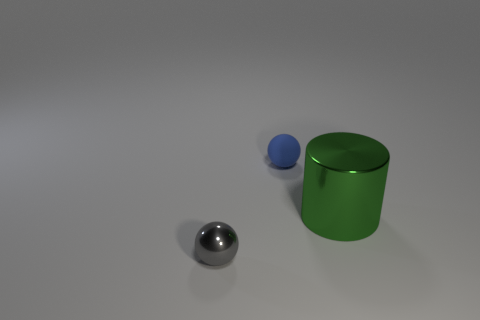How does the lighting in the image affect the appearance of the objects? The lighting in the image appears overhead and slightly angled, casting soft shadows directly under and to the left side of the objects. This creates a gentle contrast and gives the objects a three-dimensional look, enhancing their shapes and textures, and accentuating the reflective quality of the metal sphere.  What mood do the colors and lighting in the image convey? The colors and lighting in the image convey a clean and clinical feel. The neutral gray background, combined with the soft, diffused lighting, creates a calm and tranquil atmosphere. The green of the cylinder adds a touch of vibrancy to the scene, but overall, the mood is one of simplicity and order. 